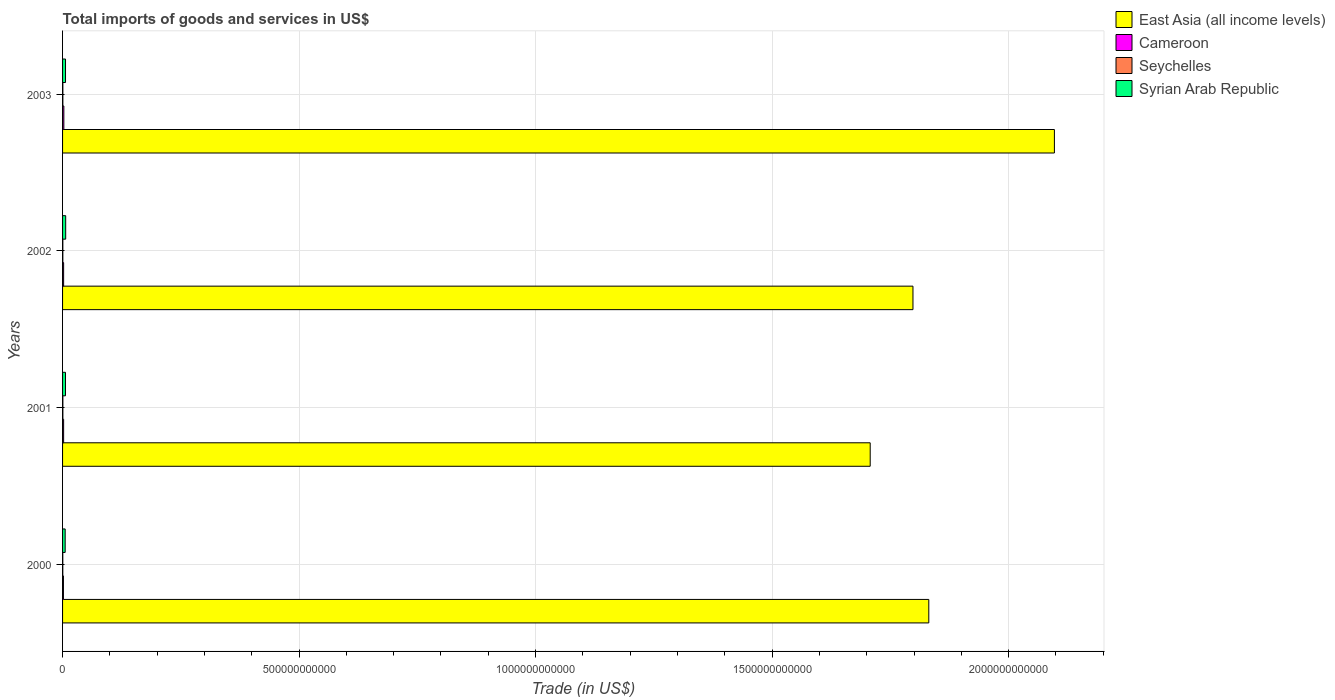How many different coloured bars are there?
Provide a short and direct response. 4. How many bars are there on the 4th tick from the top?
Your answer should be very brief. 4. What is the label of the 4th group of bars from the top?
Your answer should be very brief. 2000. In how many cases, is the number of bars for a given year not equal to the number of legend labels?
Offer a very short reply. 0. What is the total imports of goods and services in East Asia (all income levels) in 2003?
Your response must be concise. 2.10e+12. Across all years, what is the maximum total imports of goods and services in Seychelles?
Ensure brevity in your answer.  6.45e+08. Across all years, what is the minimum total imports of goods and services in East Asia (all income levels)?
Your answer should be compact. 1.71e+12. In which year was the total imports of goods and services in Cameroon maximum?
Provide a short and direct response. 2003. In which year was the total imports of goods and services in Cameroon minimum?
Your response must be concise. 2000. What is the total total imports of goods and services in Syrian Arab Republic in the graph?
Your answer should be very brief. 2.45e+1. What is the difference between the total imports of goods and services in East Asia (all income levels) in 2000 and that in 2003?
Provide a succinct answer. -2.66e+11. What is the difference between the total imports of goods and services in Seychelles in 2000 and the total imports of goods and services in Syrian Arab Republic in 2003?
Your answer should be compact. -5.73e+09. What is the average total imports of goods and services in Seychelles per year?
Provide a succinct answer. 5.89e+08. In the year 2003, what is the difference between the total imports of goods and services in East Asia (all income levels) and total imports of goods and services in Seychelles?
Give a very brief answer. 2.10e+12. In how many years, is the total imports of goods and services in Cameroon greater than 2100000000000 US$?
Make the answer very short. 0. What is the ratio of the total imports of goods and services in Cameroon in 2002 to that in 2003?
Provide a succinct answer. 0.83. Is the total imports of goods and services in Syrian Arab Republic in 2001 less than that in 2002?
Provide a short and direct response. Yes. Is the difference between the total imports of goods and services in East Asia (all income levels) in 2001 and 2003 greater than the difference between the total imports of goods and services in Seychelles in 2001 and 2003?
Provide a succinct answer. No. What is the difference between the highest and the second highest total imports of goods and services in Seychelles?
Your answer should be compact. 3.41e+07. What is the difference between the highest and the lowest total imports of goods and services in Cameroon?
Offer a very short reply. 8.86e+08. In how many years, is the total imports of goods and services in Cameroon greater than the average total imports of goods and services in Cameroon taken over all years?
Your response must be concise. 1. What does the 3rd bar from the top in 2003 represents?
Your answer should be compact. Cameroon. What does the 4th bar from the bottom in 2002 represents?
Your response must be concise. Syrian Arab Republic. Is it the case that in every year, the sum of the total imports of goods and services in Syrian Arab Republic and total imports of goods and services in Cameroon is greater than the total imports of goods and services in East Asia (all income levels)?
Your answer should be very brief. No. Are all the bars in the graph horizontal?
Your answer should be very brief. Yes. What is the difference between two consecutive major ticks on the X-axis?
Offer a terse response. 5.00e+11. Are the values on the major ticks of X-axis written in scientific E-notation?
Offer a terse response. No. Where does the legend appear in the graph?
Your response must be concise. Top right. How are the legend labels stacked?
Provide a succinct answer. Vertical. What is the title of the graph?
Keep it short and to the point. Total imports of goods and services in US$. Does "Albania" appear as one of the legend labels in the graph?
Offer a very short reply. No. What is the label or title of the X-axis?
Offer a terse response. Trade (in US$). What is the label or title of the Y-axis?
Your answer should be very brief. Years. What is the Trade (in US$) of East Asia (all income levels) in 2000?
Your answer should be compact. 1.83e+12. What is the Trade (in US$) of Cameroon in 2000?
Your answer should be very brief. 1.83e+09. What is the Trade (in US$) in Seychelles in 2000?
Your answer should be very brief. 5.04e+08. What is the Trade (in US$) of Syrian Arab Republic in 2000?
Your answer should be compact. 5.52e+09. What is the Trade (in US$) in East Asia (all income levels) in 2001?
Your response must be concise. 1.71e+12. What is the Trade (in US$) of Cameroon in 2001?
Offer a terse response. 2.24e+09. What is the Trade (in US$) in Seychelles in 2001?
Provide a short and direct response. 6.45e+08. What is the Trade (in US$) of Syrian Arab Republic in 2001?
Your answer should be compact. 6.17e+09. What is the Trade (in US$) in East Asia (all income levels) in 2002?
Offer a very short reply. 1.80e+12. What is the Trade (in US$) in Cameroon in 2002?
Ensure brevity in your answer.  2.25e+09. What is the Trade (in US$) of Seychelles in 2002?
Give a very brief answer. 5.96e+08. What is the Trade (in US$) of Syrian Arab Republic in 2002?
Your response must be concise. 6.59e+09. What is the Trade (in US$) of East Asia (all income levels) in 2003?
Ensure brevity in your answer.  2.10e+12. What is the Trade (in US$) in Cameroon in 2003?
Your answer should be compact. 2.71e+09. What is the Trade (in US$) in Seychelles in 2003?
Your answer should be compact. 6.11e+08. What is the Trade (in US$) of Syrian Arab Republic in 2003?
Offer a terse response. 6.24e+09. Across all years, what is the maximum Trade (in US$) in East Asia (all income levels)?
Provide a short and direct response. 2.10e+12. Across all years, what is the maximum Trade (in US$) of Cameroon?
Provide a succinct answer. 2.71e+09. Across all years, what is the maximum Trade (in US$) in Seychelles?
Your response must be concise. 6.45e+08. Across all years, what is the maximum Trade (in US$) of Syrian Arab Republic?
Provide a succinct answer. 6.59e+09. Across all years, what is the minimum Trade (in US$) in East Asia (all income levels)?
Keep it short and to the point. 1.71e+12. Across all years, what is the minimum Trade (in US$) of Cameroon?
Keep it short and to the point. 1.83e+09. Across all years, what is the minimum Trade (in US$) of Seychelles?
Provide a short and direct response. 5.04e+08. Across all years, what is the minimum Trade (in US$) in Syrian Arab Republic?
Keep it short and to the point. 5.52e+09. What is the total Trade (in US$) of East Asia (all income levels) in the graph?
Provide a succinct answer. 7.43e+12. What is the total Trade (in US$) in Cameroon in the graph?
Offer a very short reply. 9.03e+09. What is the total Trade (in US$) in Seychelles in the graph?
Ensure brevity in your answer.  2.35e+09. What is the total Trade (in US$) of Syrian Arab Republic in the graph?
Provide a short and direct response. 2.45e+1. What is the difference between the Trade (in US$) in East Asia (all income levels) in 2000 and that in 2001?
Offer a very short reply. 1.24e+11. What is the difference between the Trade (in US$) of Cameroon in 2000 and that in 2001?
Your answer should be compact. -4.10e+08. What is the difference between the Trade (in US$) of Seychelles in 2000 and that in 2001?
Your answer should be very brief. -1.41e+08. What is the difference between the Trade (in US$) of Syrian Arab Republic in 2000 and that in 2001?
Provide a short and direct response. -6.45e+08. What is the difference between the Trade (in US$) in East Asia (all income levels) in 2000 and that in 2002?
Give a very brief answer. 3.35e+1. What is the difference between the Trade (in US$) of Cameroon in 2000 and that in 2002?
Your response must be concise. -4.28e+08. What is the difference between the Trade (in US$) in Seychelles in 2000 and that in 2002?
Offer a terse response. -9.20e+07. What is the difference between the Trade (in US$) of Syrian Arab Republic in 2000 and that in 2002?
Ensure brevity in your answer.  -1.07e+09. What is the difference between the Trade (in US$) of East Asia (all income levels) in 2000 and that in 2003?
Provide a short and direct response. -2.66e+11. What is the difference between the Trade (in US$) of Cameroon in 2000 and that in 2003?
Offer a very short reply. -8.86e+08. What is the difference between the Trade (in US$) in Seychelles in 2000 and that in 2003?
Offer a terse response. -1.07e+08. What is the difference between the Trade (in US$) of Syrian Arab Republic in 2000 and that in 2003?
Provide a succinct answer. -7.12e+08. What is the difference between the Trade (in US$) of East Asia (all income levels) in 2001 and that in 2002?
Provide a short and direct response. -9.04e+1. What is the difference between the Trade (in US$) of Cameroon in 2001 and that in 2002?
Keep it short and to the point. -1.77e+07. What is the difference between the Trade (in US$) of Seychelles in 2001 and that in 2002?
Offer a very short reply. 4.91e+07. What is the difference between the Trade (in US$) in Syrian Arab Republic in 2001 and that in 2002?
Ensure brevity in your answer.  -4.23e+08. What is the difference between the Trade (in US$) in East Asia (all income levels) in 2001 and that in 2003?
Your response must be concise. -3.89e+11. What is the difference between the Trade (in US$) in Cameroon in 2001 and that in 2003?
Make the answer very short. -4.76e+08. What is the difference between the Trade (in US$) in Seychelles in 2001 and that in 2003?
Keep it short and to the point. 3.41e+07. What is the difference between the Trade (in US$) of Syrian Arab Republic in 2001 and that in 2003?
Ensure brevity in your answer.  -6.74e+07. What is the difference between the Trade (in US$) of East Asia (all income levels) in 2002 and that in 2003?
Ensure brevity in your answer.  -2.99e+11. What is the difference between the Trade (in US$) in Cameroon in 2002 and that in 2003?
Offer a very short reply. -4.58e+08. What is the difference between the Trade (in US$) in Seychelles in 2002 and that in 2003?
Offer a very short reply. -1.50e+07. What is the difference between the Trade (in US$) of Syrian Arab Republic in 2002 and that in 2003?
Give a very brief answer. 3.56e+08. What is the difference between the Trade (in US$) in East Asia (all income levels) in 2000 and the Trade (in US$) in Cameroon in 2001?
Offer a terse response. 1.83e+12. What is the difference between the Trade (in US$) of East Asia (all income levels) in 2000 and the Trade (in US$) of Seychelles in 2001?
Give a very brief answer. 1.83e+12. What is the difference between the Trade (in US$) in East Asia (all income levels) in 2000 and the Trade (in US$) in Syrian Arab Republic in 2001?
Offer a terse response. 1.83e+12. What is the difference between the Trade (in US$) in Cameroon in 2000 and the Trade (in US$) in Seychelles in 2001?
Offer a very short reply. 1.18e+09. What is the difference between the Trade (in US$) of Cameroon in 2000 and the Trade (in US$) of Syrian Arab Republic in 2001?
Your answer should be compact. -4.34e+09. What is the difference between the Trade (in US$) of Seychelles in 2000 and the Trade (in US$) of Syrian Arab Republic in 2001?
Your answer should be compact. -5.66e+09. What is the difference between the Trade (in US$) in East Asia (all income levels) in 2000 and the Trade (in US$) in Cameroon in 2002?
Ensure brevity in your answer.  1.83e+12. What is the difference between the Trade (in US$) in East Asia (all income levels) in 2000 and the Trade (in US$) in Seychelles in 2002?
Provide a succinct answer. 1.83e+12. What is the difference between the Trade (in US$) in East Asia (all income levels) in 2000 and the Trade (in US$) in Syrian Arab Republic in 2002?
Offer a terse response. 1.82e+12. What is the difference between the Trade (in US$) of Cameroon in 2000 and the Trade (in US$) of Seychelles in 2002?
Offer a terse response. 1.23e+09. What is the difference between the Trade (in US$) in Cameroon in 2000 and the Trade (in US$) in Syrian Arab Republic in 2002?
Make the answer very short. -4.77e+09. What is the difference between the Trade (in US$) in Seychelles in 2000 and the Trade (in US$) in Syrian Arab Republic in 2002?
Give a very brief answer. -6.09e+09. What is the difference between the Trade (in US$) in East Asia (all income levels) in 2000 and the Trade (in US$) in Cameroon in 2003?
Make the answer very short. 1.83e+12. What is the difference between the Trade (in US$) of East Asia (all income levels) in 2000 and the Trade (in US$) of Seychelles in 2003?
Make the answer very short. 1.83e+12. What is the difference between the Trade (in US$) in East Asia (all income levels) in 2000 and the Trade (in US$) in Syrian Arab Republic in 2003?
Make the answer very short. 1.83e+12. What is the difference between the Trade (in US$) in Cameroon in 2000 and the Trade (in US$) in Seychelles in 2003?
Provide a succinct answer. 1.22e+09. What is the difference between the Trade (in US$) in Cameroon in 2000 and the Trade (in US$) in Syrian Arab Republic in 2003?
Your answer should be very brief. -4.41e+09. What is the difference between the Trade (in US$) in Seychelles in 2000 and the Trade (in US$) in Syrian Arab Republic in 2003?
Offer a terse response. -5.73e+09. What is the difference between the Trade (in US$) in East Asia (all income levels) in 2001 and the Trade (in US$) in Cameroon in 2002?
Your answer should be compact. 1.71e+12. What is the difference between the Trade (in US$) of East Asia (all income levels) in 2001 and the Trade (in US$) of Seychelles in 2002?
Your response must be concise. 1.71e+12. What is the difference between the Trade (in US$) of East Asia (all income levels) in 2001 and the Trade (in US$) of Syrian Arab Republic in 2002?
Keep it short and to the point. 1.70e+12. What is the difference between the Trade (in US$) of Cameroon in 2001 and the Trade (in US$) of Seychelles in 2002?
Offer a terse response. 1.64e+09. What is the difference between the Trade (in US$) in Cameroon in 2001 and the Trade (in US$) in Syrian Arab Republic in 2002?
Your answer should be very brief. -4.36e+09. What is the difference between the Trade (in US$) in Seychelles in 2001 and the Trade (in US$) in Syrian Arab Republic in 2002?
Provide a short and direct response. -5.95e+09. What is the difference between the Trade (in US$) of East Asia (all income levels) in 2001 and the Trade (in US$) of Cameroon in 2003?
Your answer should be compact. 1.70e+12. What is the difference between the Trade (in US$) in East Asia (all income levels) in 2001 and the Trade (in US$) in Seychelles in 2003?
Your answer should be very brief. 1.71e+12. What is the difference between the Trade (in US$) of East Asia (all income levels) in 2001 and the Trade (in US$) of Syrian Arab Republic in 2003?
Provide a succinct answer. 1.70e+12. What is the difference between the Trade (in US$) of Cameroon in 2001 and the Trade (in US$) of Seychelles in 2003?
Offer a terse response. 1.63e+09. What is the difference between the Trade (in US$) of Cameroon in 2001 and the Trade (in US$) of Syrian Arab Republic in 2003?
Provide a short and direct response. -4.00e+09. What is the difference between the Trade (in US$) in Seychelles in 2001 and the Trade (in US$) in Syrian Arab Republic in 2003?
Keep it short and to the point. -5.59e+09. What is the difference between the Trade (in US$) of East Asia (all income levels) in 2002 and the Trade (in US$) of Cameroon in 2003?
Give a very brief answer. 1.80e+12. What is the difference between the Trade (in US$) of East Asia (all income levels) in 2002 and the Trade (in US$) of Seychelles in 2003?
Your answer should be compact. 1.80e+12. What is the difference between the Trade (in US$) in East Asia (all income levels) in 2002 and the Trade (in US$) in Syrian Arab Republic in 2003?
Keep it short and to the point. 1.79e+12. What is the difference between the Trade (in US$) of Cameroon in 2002 and the Trade (in US$) of Seychelles in 2003?
Make the answer very short. 1.64e+09. What is the difference between the Trade (in US$) of Cameroon in 2002 and the Trade (in US$) of Syrian Arab Republic in 2003?
Offer a very short reply. -3.98e+09. What is the difference between the Trade (in US$) of Seychelles in 2002 and the Trade (in US$) of Syrian Arab Republic in 2003?
Your response must be concise. -5.64e+09. What is the average Trade (in US$) of East Asia (all income levels) per year?
Ensure brevity in your answer.  1.86e+12. What is the average Trade (in US$) in Cameroon per year?
Your answer should be compact. 2.26e+09. What is the average Trade (in US$) of Seychelles per year?
Your response must be concise. 5.89e+08. What is the average Trade (in US$) of Syrian Arab Republic per year?
Provide a short and direct response. 6.13e+09. In the year 2000, what is the difference between the Trade (in US$) in East Asia (all income levels) and Trade (in US$) in Cameroon?
Make the answer very short. 1.83e+12. In the year 2000, what is the difference between the Trade (in US$) of East Asia (all income levels) and Trade (in US$) of Seychelles?
Make the answer very short. 1.83e+12. In the year 2000, what is the difference between the Trade (in US$) in East Asia (all income levels) and Trade (in US$) in Syrian Arab Republic?
Your response must be concise. 1.83e+12. In the year 2000, what is the difference between the Trade (in US$) in Cameroon and Trade (in US$) in Seychelles?
Make the answer very short. 1.32e+09. In the year 2000, what is the difference between the Trade (in US$) of Cameroon and Trade (in US$) of Syrian Arab Republic?
Your response must be concise. -3.70e+09. In the year 2000, what is the difference between the Trade (in US$) in Seychelles and Trade (in US$) in Syrian Arab Republic?
Provide a short and direct response. -5.02e+09. In the year 2001, what is the difference between the Trade (in US$) in East Asia (all income levels) and Trade (in US$) in Cameroon?
Keep it short and to the point. 1.71e+12. In the year 2001, what is the difference between the Trade (in US$) in East Asia (all income levels) and Trade (in US$) in Seychelles?
Your response must be concise. 1.71e+12. In the year 2001, what is the difference between the Trade (in US$) in East Asia (all income levels) and Trade (in US$) in Syrian Arab Republic?
Offer a very short reply. 1.70e+12. In the year 2001, what is the difference between the Trade (in US$) in Cameroon and Trade (in US$) in Seychelles?
Your answer should be very brief. 1.59e+09. In the year 2001, what is the difference between the Trade (in US$) in Cameroon and Trade (in US$) in Syrian Arab Republic?
Your answer should be very brief. -3.93e+09. In the year 2001, what is the difference between the Trade (in US$) of Seychelles and Trade (in US$) of Syrian Arab Republic?
Your answer should be compact. -5.52e+09. In the year 2002, what is the difference between the Trade (in US$) in East Asia (all income levels) and Trade (in US$) in Cameroon?
Provide a succinct answer. 1.80e+12. In the year 2002, what is the difference between the Trade (in US$) of East Asia (all income levels) and Trade (in US$) of Seychelles?
Ensure brevity in your answer.  1.80e+12. In the year 2002, what is the difference between the Trade (in US$) of East Asia (all income levels) and Trade (in US$) of Syrian Arab Republic?
Make the answer very short. 1.79e+12. In the year 2002, what is the difference between the Trade (in US$) of Cameroon and Trade (in US$) of Seychelles?
Your response must be concise. 1.66e+09. In the year 2002, what is the difference between the Trade (in US$) in Cameroon and Trade (in US$) in Syrian Arab Republic?
Offer a terse response. -4.34e+09. In the year 2002, what is the difference between the Trade (in US$) of Seychelles and Trade (in US$) of Syrian Arab Republic?
Provide a short and direct response. -6.00e+09. In the year 2003, what is the difference between the Trade (in US$) in East Asia (all income levels) and Trade (in US$) in Cameroon?
Your response must be concise. 2.09e+12. In the year 2003, what is the difference between the Trade (in US$) in East Asia (all income levels) and Trade (in US$) in Seychelles?
Your response must be concise. 2.10e+12. In the year 2003, what is the difference between the Trade (in US$) of East Asia (all income levels) and Trade (in US$) of Syrian Arab Republic?
Provide a short and direct response. 2.09e+12. In the year 2003, what is the difference between the Trade (in US$) of Cameroon and Trade (in US$) of Seychelles?
Your response must be concise. 2.10e+09. In the year 2003, what is the difference between the Trade (in US$) in Cameroon and Trade (in US$) in Syrian Arab Republic?
Offer a terse response. -3.52e+09. In the year 2003, what is the difference between the Trade (in US$) in Seychelles and Trade (in US$) in Syrian Arab Republic?
Ensure brevity in your answer.  -5.63e+09. What is the ratio of the Trade (in US$) in East Asia (all income levels) in 2000 to that in 2001?
Provide a succinct answer. 1.07. What is the ratio of the Trade (in US$) of Cameroon in 2000 to that in 2001?
Keep it short and to the point. 0.82. What is the ratio of the Trade (in US$) in Seychelles in 2000 to that in 2001?
Give a very brief answer. 0.78. What is the ratio of the Trade (in US$) of Syrian Arab Republic in 2000 to that in 2001?
Offer a terse response. 0.9. What is the ratio of the Trade (in US$) in East Asia (all income levels) in 2000 to that in 2002?
Your response must be concise. 1.02. What is the ratio of the Trade (in US$) of Cameroon in 2000 to that in 2002?
Keep it short and to the point. 0.81. What is the ratio of the Trade (in US$) in Seychelles in 2000 to that in 2002?
Ensure brevity in your answer.  0.85. What is the ratio of the Trade (in US$) of Syrian Arab Republic in 2000 to that in 2002?
Keep it short and to the point. 0.84. What is the ratio of the Trade (in US$) in East Asia (all income levels) in 2000 to that in 2003?
Provide a succinct answer. 0.87. What is the ratio of the Trade (in US$) of Cameroon in 2000 to that in 2003?
Ensure brevity in your answer.  0.67. What is the ratio of the Trade (in US$) of Seychelles in 2000 to that in 2003?
Your response must be concise. 0.82. What is the ratio of the Trade (in US$) of Syrian Arab Republic in 2000 to that in 2003?
Provide a short and direct response. 0.89. What is the ratio of the Trade (in US$) in East Asia (all income levels) in 2001 to that in 2002?
Keep it short and to the point. 0.95. What is the ratio of the Trade (in US$) of Seychelles in 2001 to that in 2002?
Offer a terse response. 1.08. What is the ratio of the Trade (in US$) in Syrian Arab Republic in 2001 to that in 2002?
Offer a terse response. 0.94. What is the ratio of the Trade (in US$) in East Asia (all income levels) in 2001 to that in 2003?
Provide a succinct answer. 0.81. What is the ratio of the Trade (in US$) of Cameroon in 2001 to that in 2003?
Your response must be concise. 0.82. What is the ratio of the Trade (in US$) of Seychelles in 2001 to that in 2003?
Make the answer very short. 1.06. What is the ratio of the Trade (in US$) in Syrian Arab Republic in 2001 to that in 2003?
Ensure brevity in your answer.  0.99. What is the ratio of the Trade (in US$) of East Asia (all income levels) in 2002 to that in 2003?
Keep it short and to the point. 0.86. What is the ratio of the Trade (in US$) of Cameroon in 2002 to that in 2003?
Provide a succinct answer. 0.83. What is the ratio of the Trade (in US$) of Seychelles in 2002 to that in 2003?
Keep it short and to the point. 0.98. What is the ratio of the Trade (in US$) of Syrian Arab Republic in 2002 to that in 2003?
Keep it short and to the point. 1.06. What is the difference between the highest and the second highest Trade (in US$) of East Asia (all income levels)?
Ensure brevity in your answer.  2.66e+11. What is the difference between the highest and the second highest Trade (in US$) of Cameroon?
Provide a short and direct response. 4.58e+08. What is the difference between the highest and the second highest Trade (in US$) in Seychelles?
Provide a short and direct response. 3.41e+07. What is the difference between the highest and the second highest Trade (in US$) in Syrian Arab Republic?
Make the answer very short. 3.56e+08. What is the difference between the highest and the lowest Trade (in US$) of East Asia (all income levels)?
Provide a succinct answer. 3.89e+11. What is the difference between the highest and the lowest Trade (in US$) of Cameroon?
Your answer should be very brief. 8.86e+08. What is the difference between the highest and the lowest Trade (in US$) in Seychelles?
Your response must be concise. 1.41e+08. What is the difference between the highest and the lowest Trade (in US$) of Syrian Arab Republic?
Offer a very short reply. 1.07e+09. 